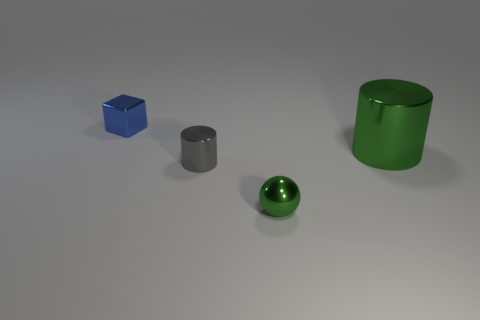Add 1 red metallic cylinders. How many objects exist? 5 Subtract all spheres. How many objects are left? 3 Add 3 tiny green spheres. How many tiny green spheres are left? 4 Add 3 large yellow matte cylinders. How many large yellow matte cylinders exist? 3 Subtract 0 yellow cylinders. How many objects are left? 4 Subtract all red matte cylinders. Subtract all metal cylinders. How many objects are left? 2 